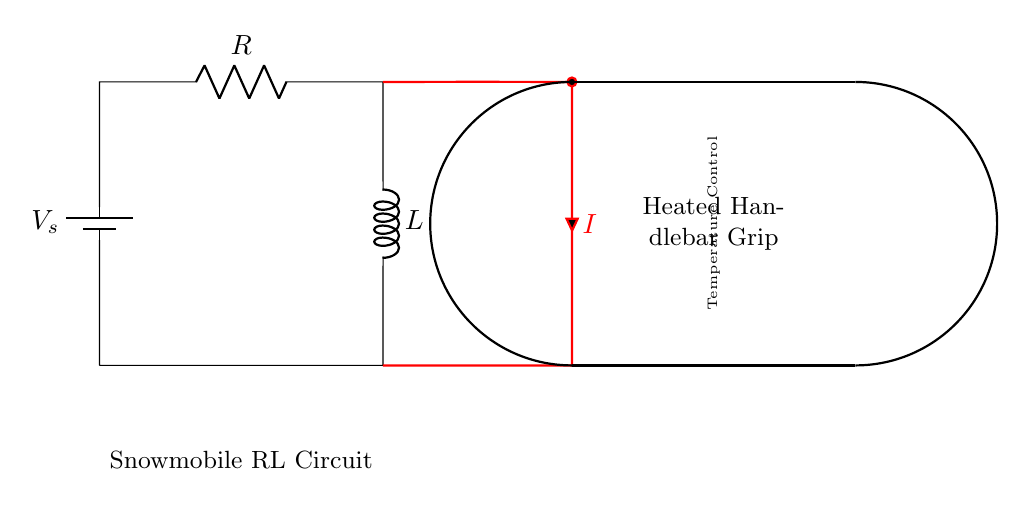What type of circuit is shown? The diagram presents an RL circuit, which consists of a resistor and an inductor connected in series. This is indicated by the presence of both R and L components in the circuit.
Answer: RL circuit What does the symbol "V_s" represent? "V_s" in the circuit is the source voltage, which provides electrical energy to drive the current through the circuit. It is common to denote the voltage source with a "V" prefix.
Answer: Source voltage What component controls the temperature? The heated handlebar grip is designed to manage the temperature by providing heat, which is created when current flows through the resistor. This specific design is to maintain a comfortable grip temperature.
Answer: Heated handlebar grip What is the symbol representing the inductor? The inductor is represented by a coiled line in the circuit diagram, which is the standard notation for an inductor in circuit symbols. This visually distinguishes it from the resistor.
Answer: Coiled line What happens to current if the resistance increases? If resistance increases in the circuit, the overall current flowing through the circuit decreases according to Ohm's law, which states that current is inversely proportional to resistance.
Answer: Decreases How does the inductor affect the circuit behavior? The inductor causes a delay in the current change and stores energy in the magnetic field. This property is especially important in smoothing out the current flow when adjusting temperature control in heated grips.
Answer: Delays current change What are the two main components of this circuit? The circuit primarily consists of two components: a resistor and an inductor. These components can illustrate how temperature control might be applied to heated handlebar grips effectively.
Answer: Resistor and inductor 